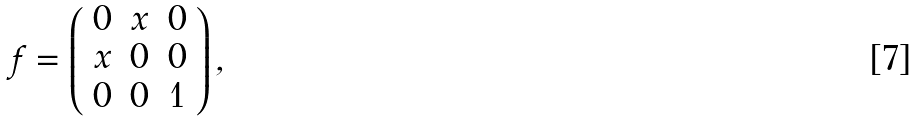<formula> <loc_0><loc_0><loc_500><loc_500>f = \left ( \begin{array} { c c c } 0 & x & 0 \\ x & 0 & 0 \\ 0 & 0 & 1 \end{array} \right ) ,</formula> 